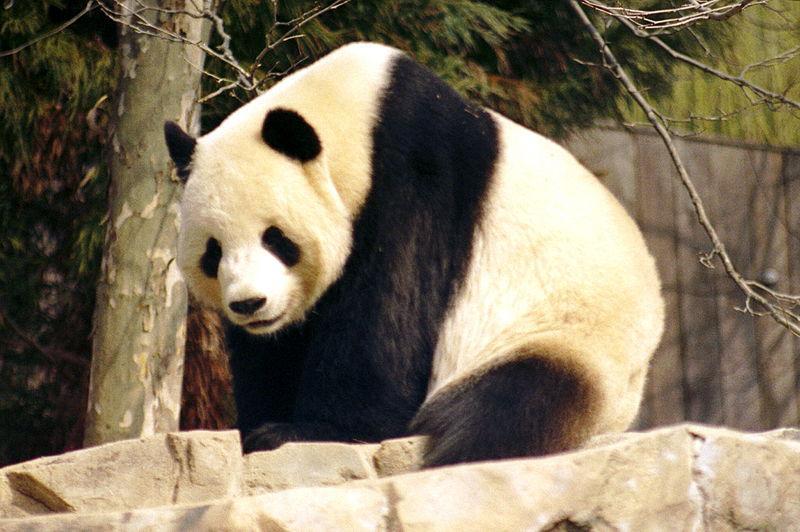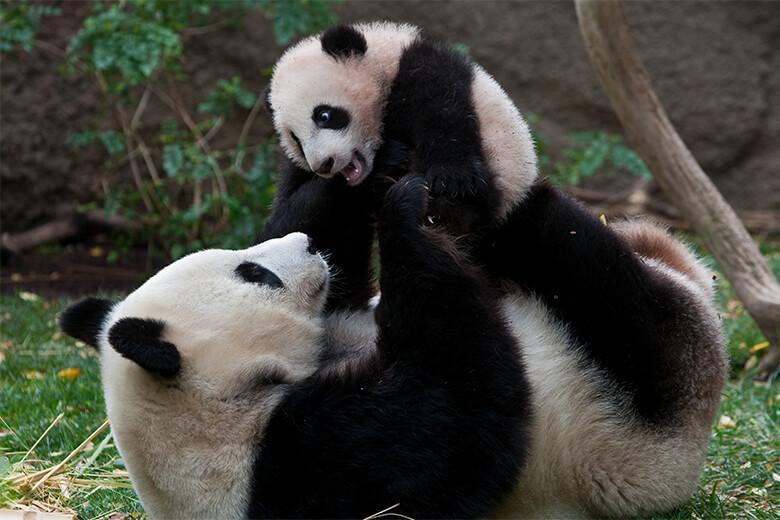The first image is the image on the left, the second image is the image on the right. Given the left and right images, does the statement "One image has a baby panda being held while on top of an adult panda that is on its back." hold true? Answer yes or no. Yes. The first image is the image on the left, the second image is the image on the right. For the images displayed, is the sentence "At least one of the images has a big panda with a much smaller panda." factually correct? Answer yes or no. Yes. 